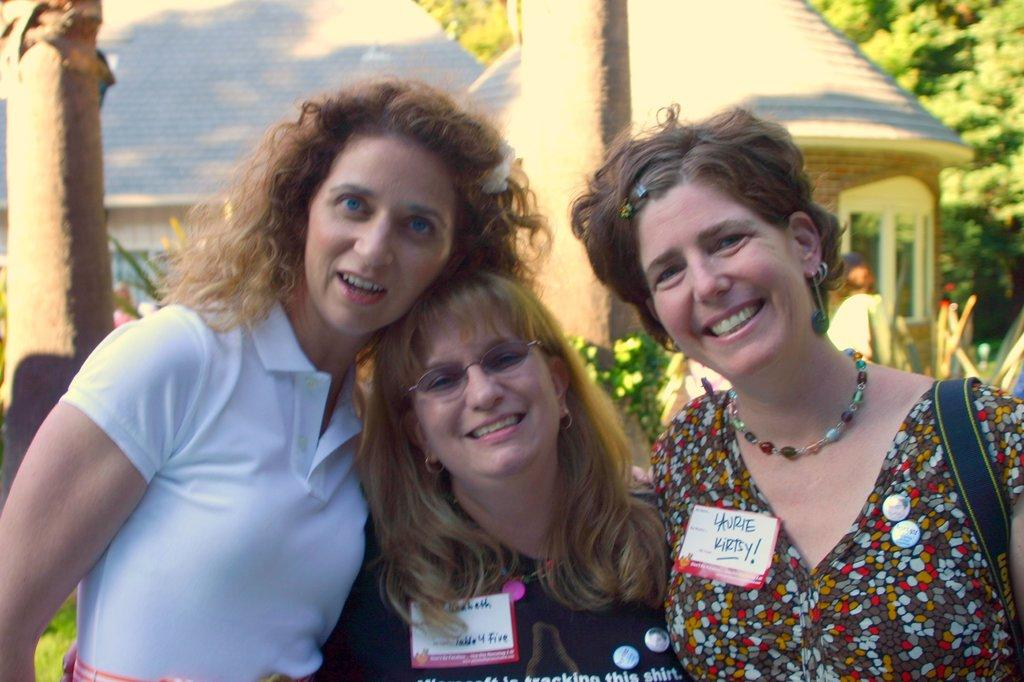How many people are in the image? There are persons in the image, but the exact number is not specified. What can be seen in the background of the image? There are trees, houses, plants, and other objects in the background of the image. What type of flowers are being requested by the persons in the image? There is no indication in the image that the persons are requesting any flowers, and therefore no such request can be observed. 